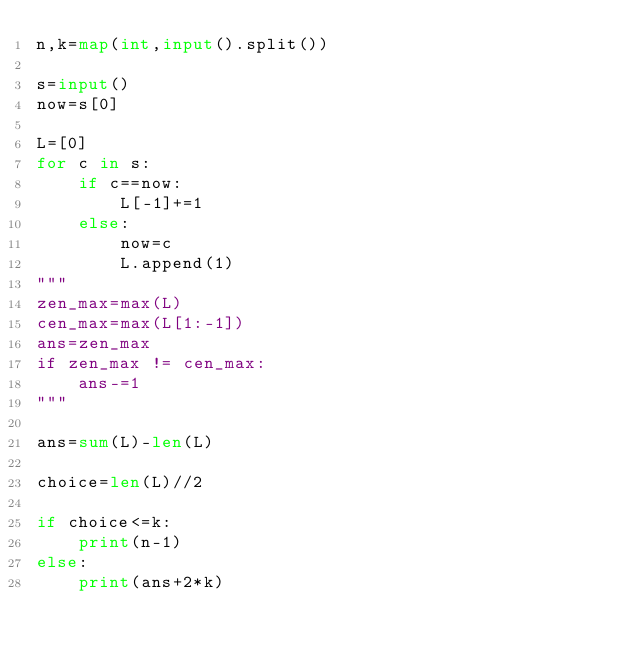<code> <loc_0><loc_0><loc_500><loc_500><_Python_>n,k=map(int,input().split())

s=input()
now=s[0]

L=[0]
for c in s:
    if c==now:
        L[-1]+=1
    else:
        now=c
        L.append(1)
"""
zen_max=max(L)
cen_max=max(L[1:-1])
ans=zen_max
if zen_max != cen_max:
    ans-=1
"""

ans=sum(L)-len(L)

choice=len(L)//2

if choice<=k:
    print(n-1)
else:
    print(ans+2*k)
</code> 